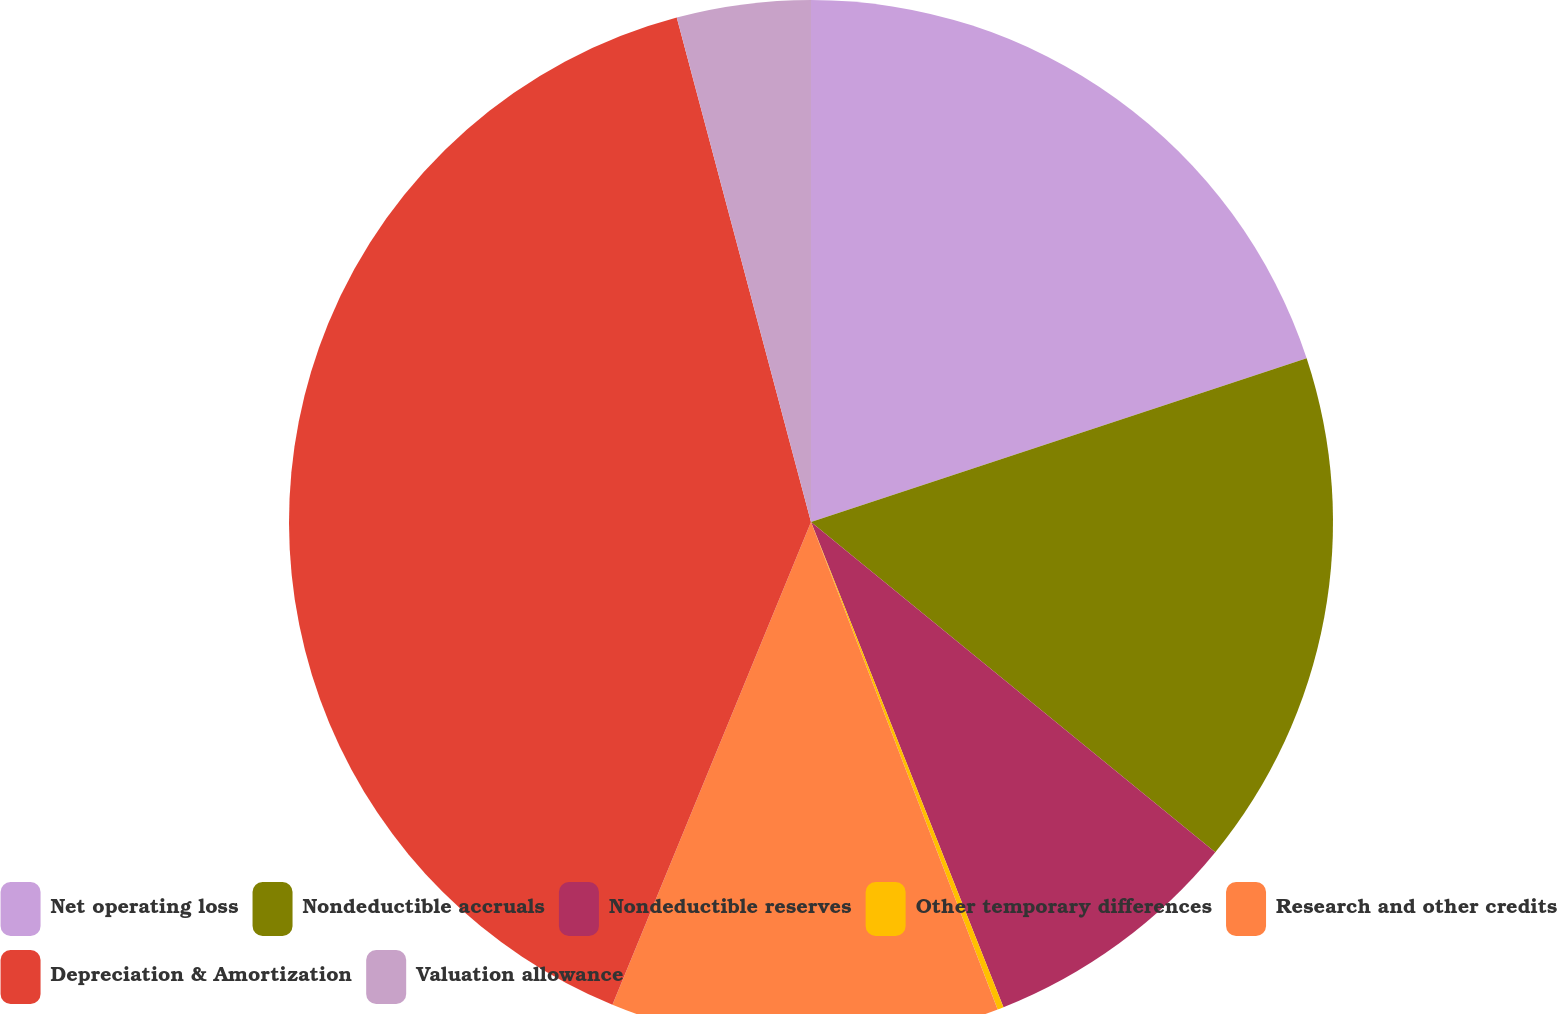Convert chart to OTSL. <chart><loc_0><loc_0><loc_500><loc_500><pie_chart><fcel>Net operating loss<fcel>Nondeductible accruals<fcel>Nondeductible reserves<fcel>Other temporary differences<fcel>Research and other credits<fcel>Depreciation & Amortization<fcel>Valuation allowance<nl><fcel>19.92%<fcel>15.98%<fcel>8.09%<fcel>0.19%<fcel>12.03%<fcel>39.65%<fcel>4.14%<nl></chart> 